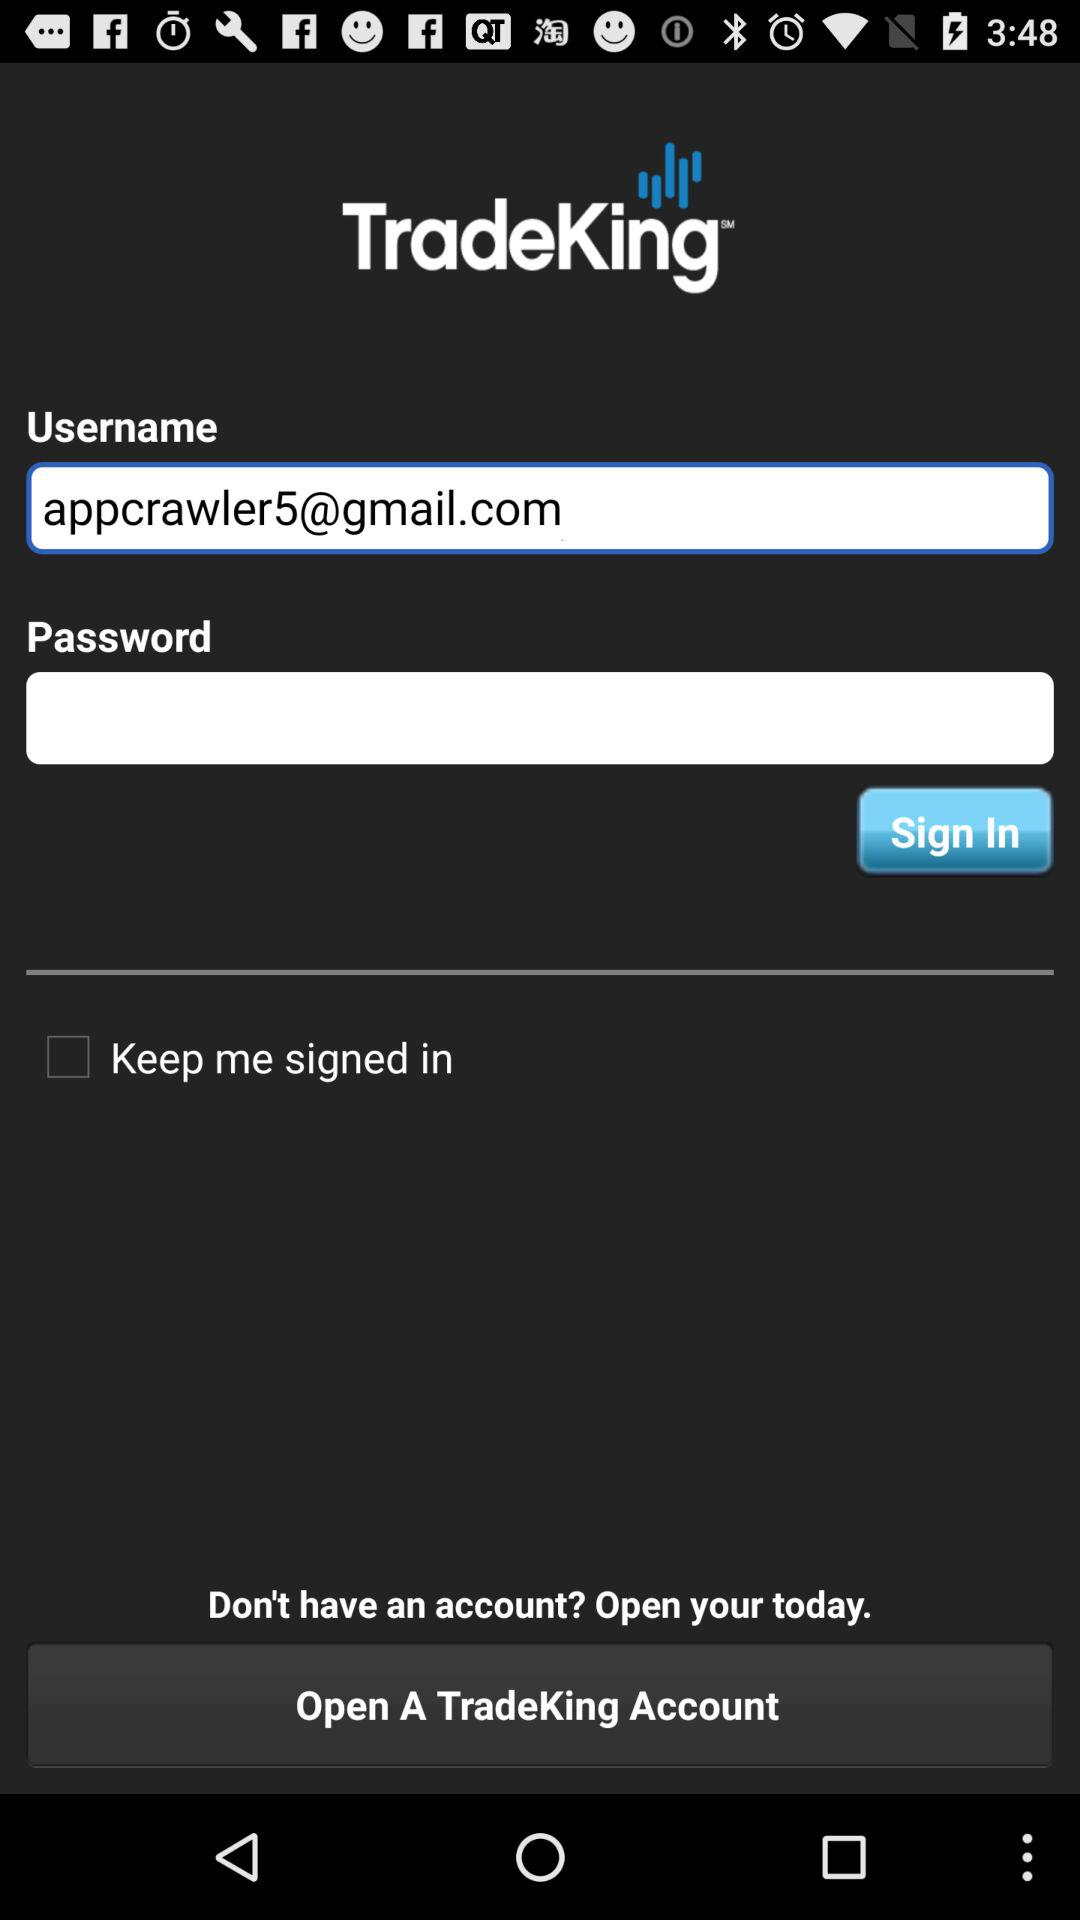What is the email address? The email address is appcrawler5@gmail.com. 